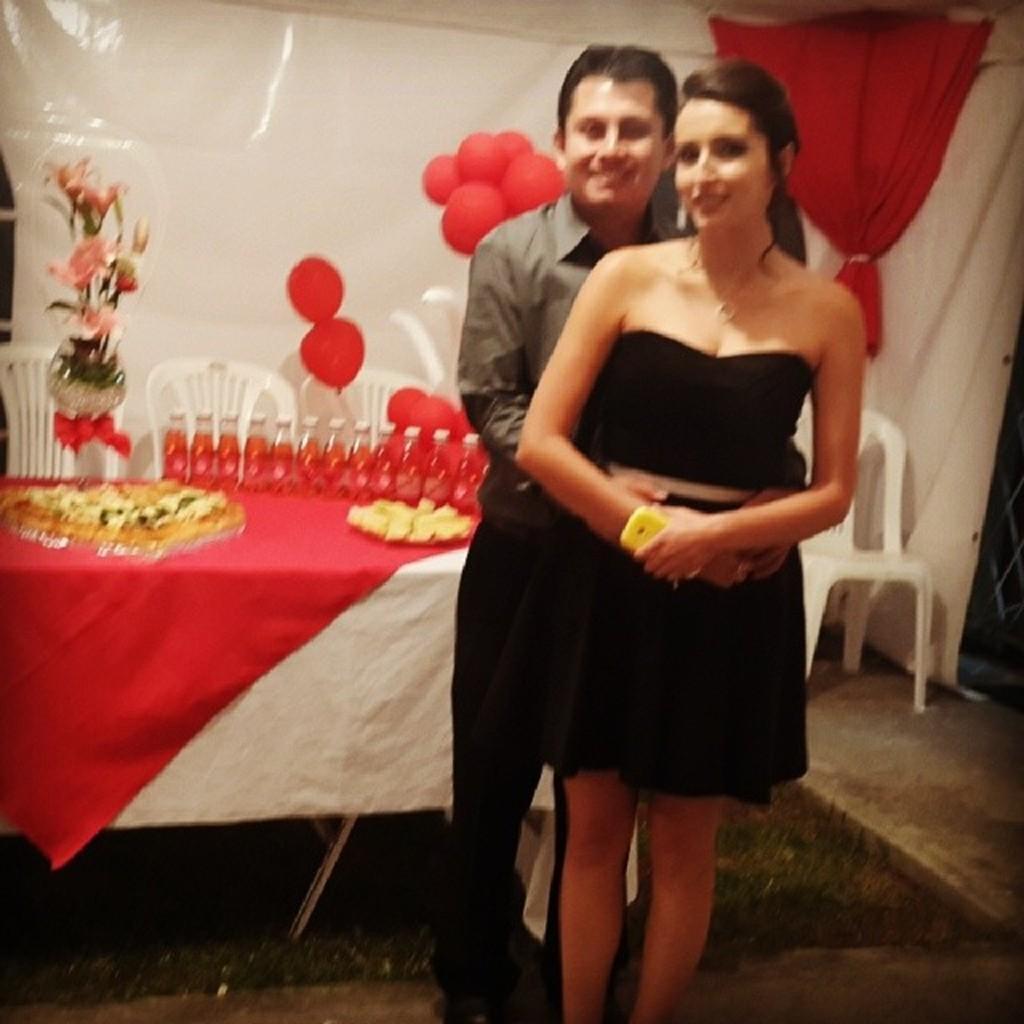Describe this image in one or two sentences. In this image, we can see persons wearing clothes. There is a table on the left side of the image covered with a cloth. This table contains bottles and some food. There are some chairs and balloons in the middle of the image. There is a curtain in the top right of the image. There is a flower vase on the left side of the image. 